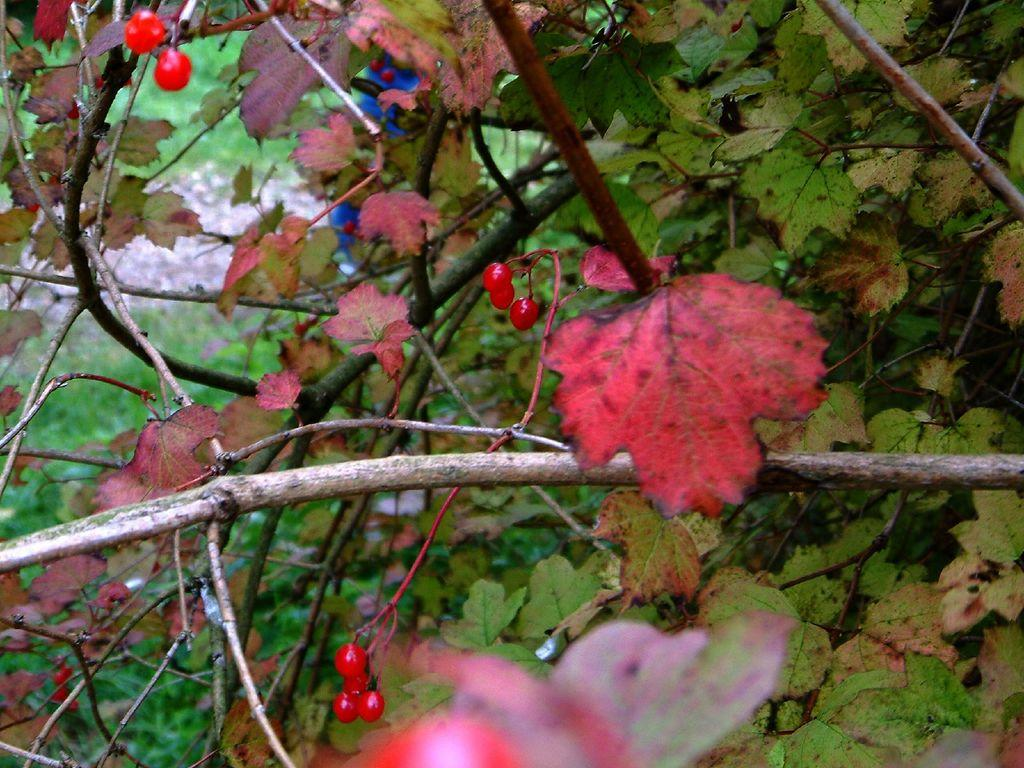What type of living organisms can be seen in the image? Plants can be seen in the image. How many sheep are present in the image? There are no sheep present in the image; it only features plants. 